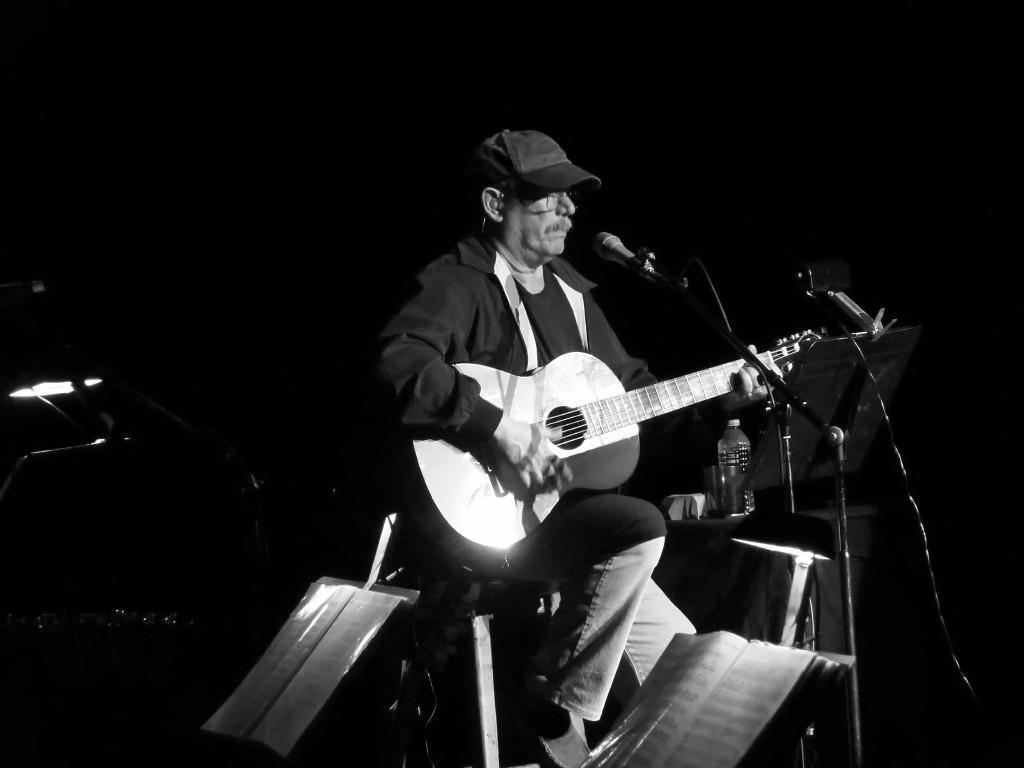What is the person in the image doing? The person is sitting and playing a guitar. Can you describe the person's attire? The person is wearing a cap. What is in front of the person? There is a microphone in front of the person. What objects can be seen at the back of the image? There are plastic bottles at the back of the image. What items are in the front of the image? There are books in the front of the image. What is the creator of the guitar thinking while playing it in the image? There is no information about the thoughts of the guitar's creator in the image, as it only shows a person playing the guitar. 